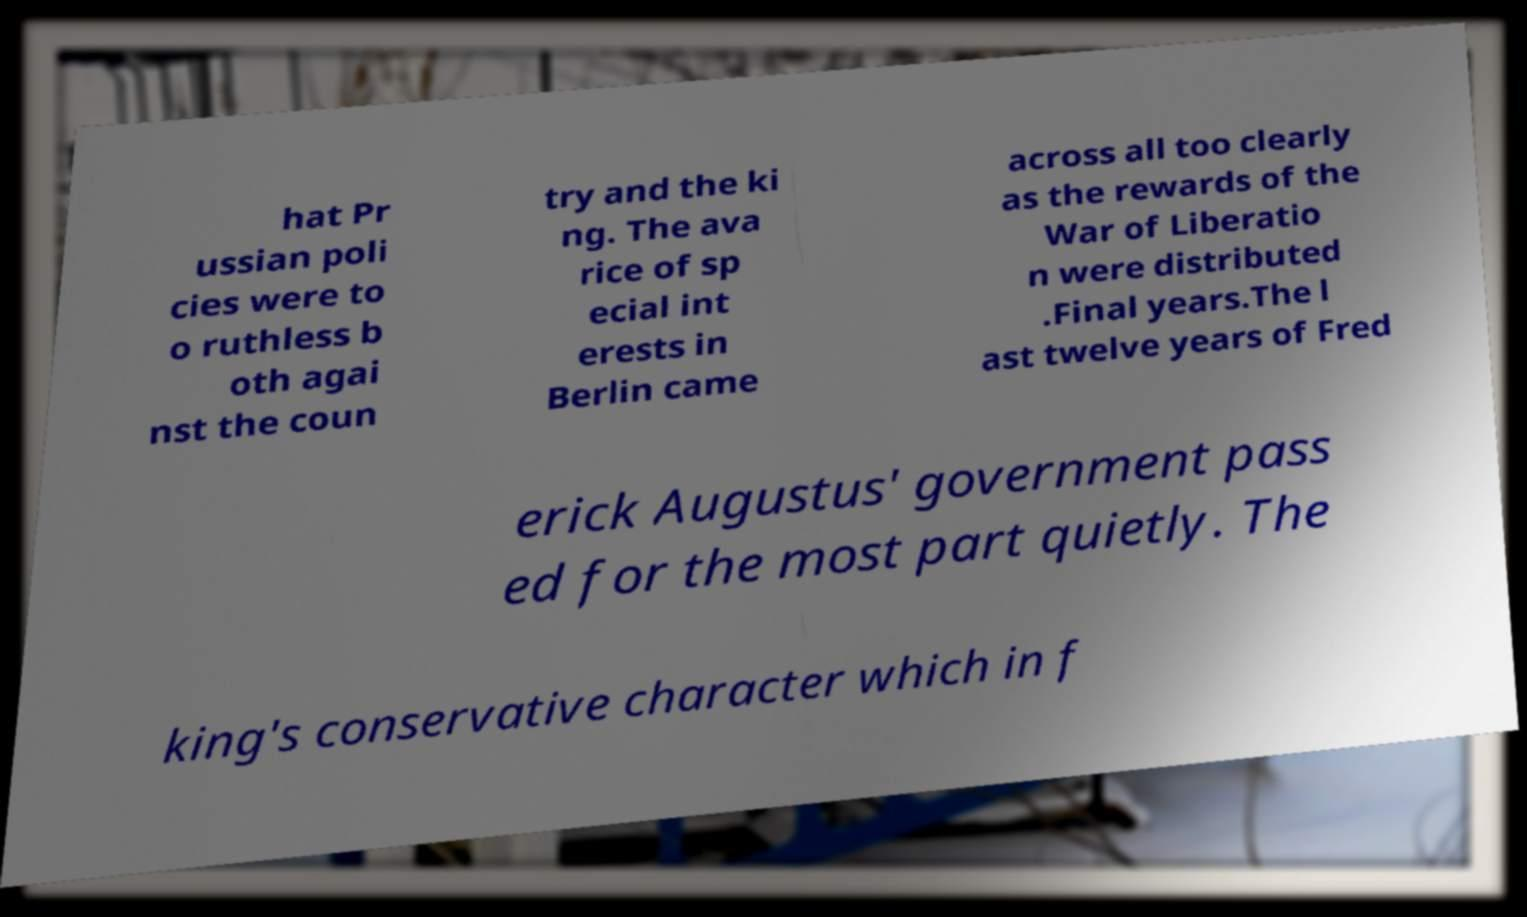Can you accurately transcribe the text from the provided image for me? hat Pr ussian poli cies were to o ruthless b oth agai nst the coun try and the ki ng. The ava rice of sp ecial int erests in Berlin came across all too clearly as the rewards of the War of Liberatio n were distributed .Final years.The l ast twelve years of Fred erick Augustus' government pass ed for the most part quietly. The king's conservative character which in f 